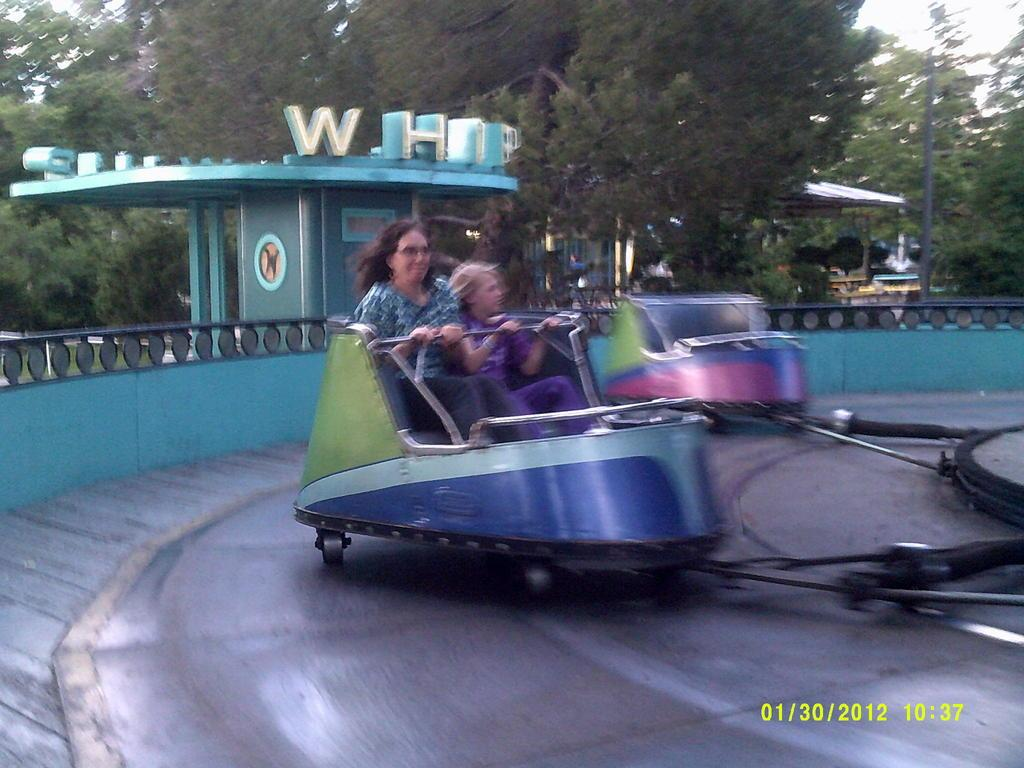How many people are in the image? There are two persons in the image. What are the persons doing in the image? The persons are sitting on a roller coaster. What can be seen in the background of the image? There are multiple trees in the background of the image. What other object is visible in the image? An electrical pole is visible in the image. What type of bike is the person riding in the image? There is no bike present in the image; the persons are sitting on a roller coaster. How does the oven affect the scene in the image? There is no oven present in the image, so it cannot affect the scene. 